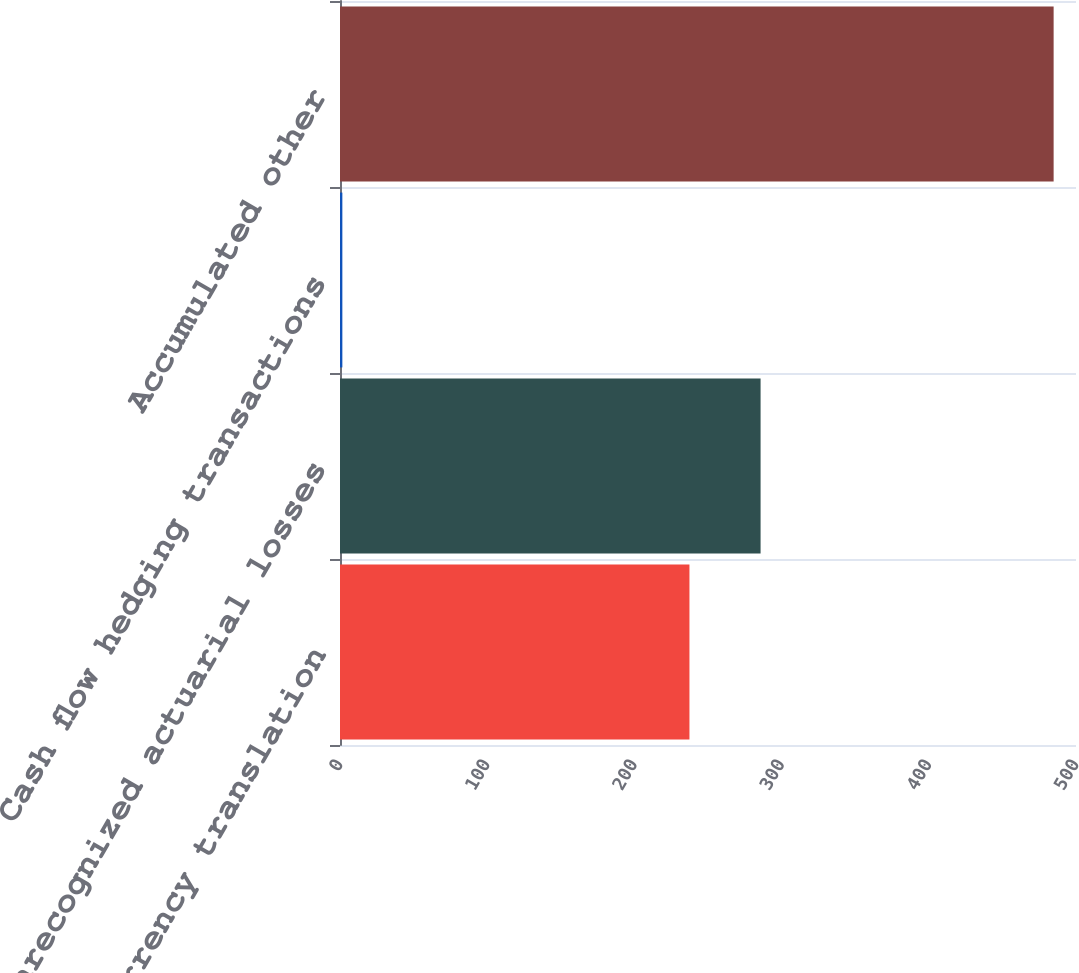<chart> <loc_0><loc_0><loc_500><loc_500><bar_chart><fcel>Foreign currency translation<fcel>Unrecognized actuarial losses<fcel>Cash flow hedging transactions<fcel>Accumulated other<nl><fcel>237.4<fcel>285.72<fcel>1.6<fcel>484.8<nl></chart> 